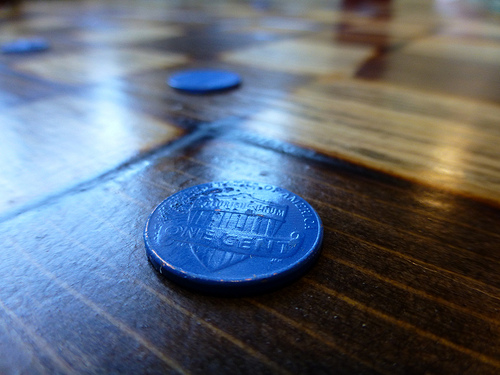<image>
Is there a coin on the table? Yes. Looking at the image, I can see the coin is positioned on top of the table, with the table providing support. 